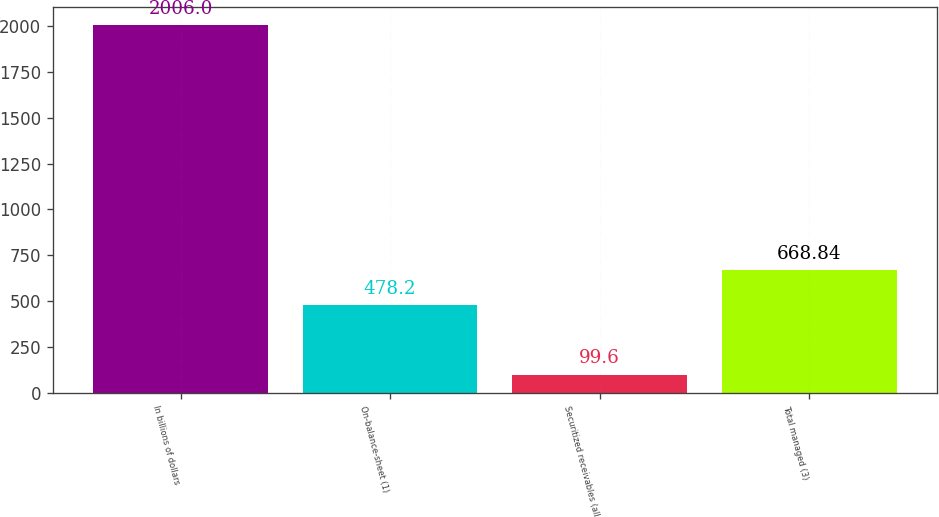<chart> <loc_0><loc_0><loc_500><loc_500><bar_chart><fcel>In billions of dollars<fcel>On-balance-sheet (1)<fcel>Securitized receivables (all<fcel>Total managed (3)<nl><fcel>2006<fcel>478.2<fcel>99.6<fcel>668.84<nl></chart> 